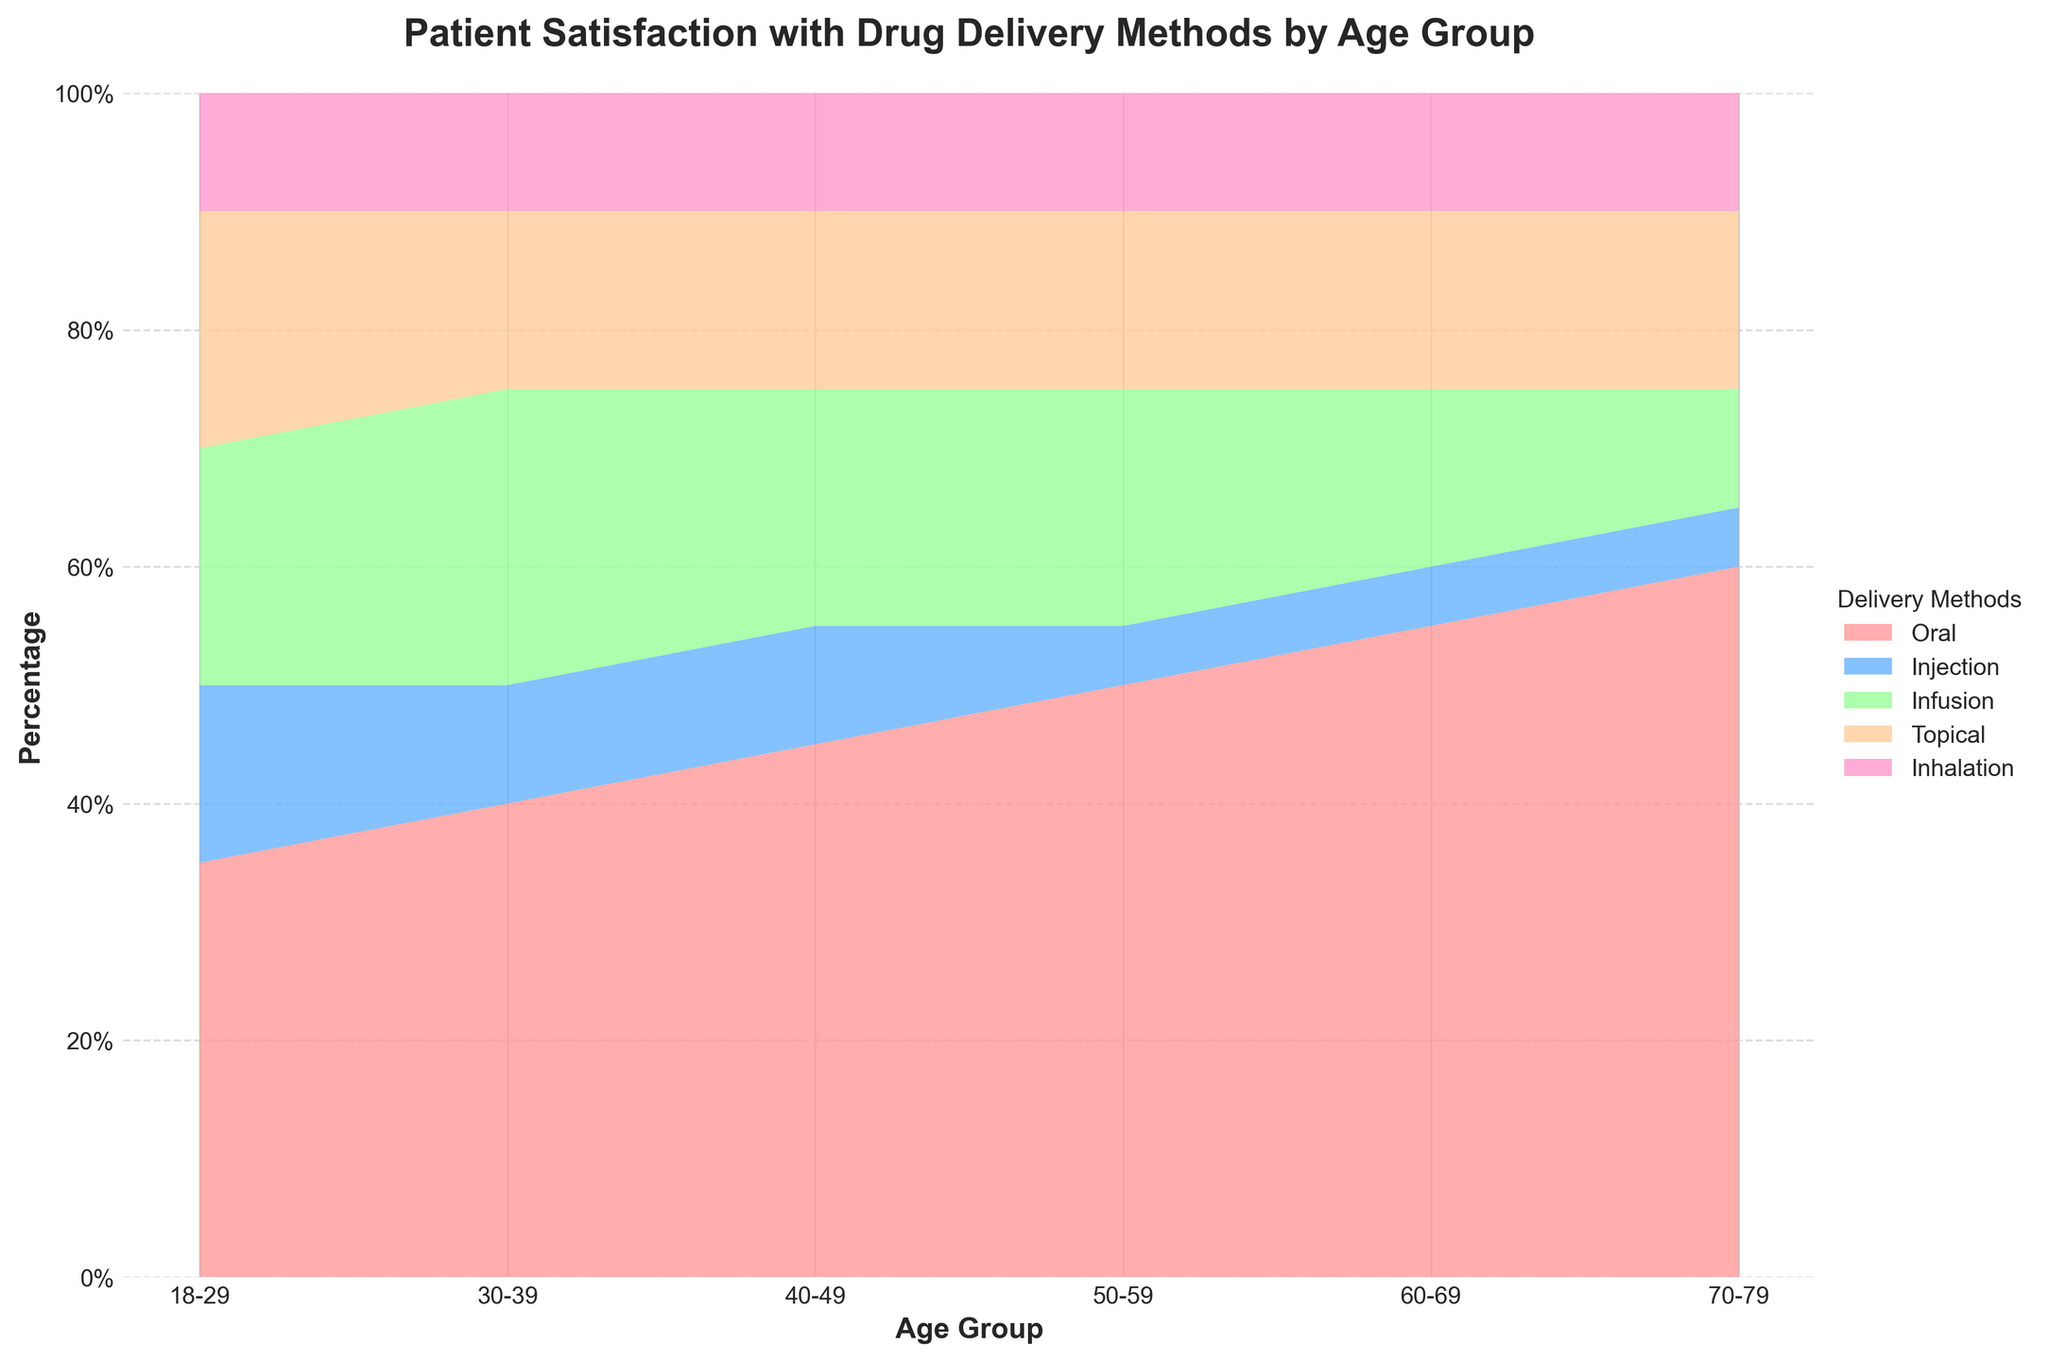What is the title of the chart? The title is displayed at the top of the chart, providing an overview of what the data represents.
Answer: Patient Satisfaction with Drug Delivery Methods by Age Group Which age group has the highest percentage of satisfaction with oral drug delivery? The height of the segment representing oral drug delivery across different age groups shows the highest percentage in the 70-79 age group.
Answer: 70-79 Which drug delivery method consistently has the lowest percentage across all age groups? By examining the segments, injection always occupies the lowest or close to the lowest area in each age group.
Answer: Injection What is the approximate percentage of patient satisfaction with infusion in the 30-39 age group? The infusion segment for the 30-39 age group closely aligns with a value of approximately 25%.
Answer: 25% How do the satisfaction levels for topical delivery change across age groups? Observing the stacked areas of topical delivery indicates it remains fairly constant at around 15%.
Answer: Fairly constant at 15% Compare the satisfaction levels of oral delivery between the 18-29 and 50-59 age groups. Oral satisfaction is around 35% for the 18-29 age group and approximately 50% for the 50-59 age group.
Answer: Higher in 50-59 In which age group is the satisfaction with inhalation the same? Observing the inhalation segment, its percentage remains consistent at 10% across all age groups.
Answer: All age groups Calculate the combined percentage of satisfaction for injection and inhalation in the 60-69 age group. Injection is 5% and inhalation is 10%, adding these yields 15%.
Answer: 15% Determine which delivery method has the most significant increase in satisfaction as the age increases from 18-29 to 70-79. Examining the oral delivery section reveals a steady increase from 35% to 60%.
Answer: Oral What is the difference in satisfaction with topical drug delivery between the 30-39 and 70-79 age groups? Both age groups show 15% satisfaction with topical drug delivery, resulting in no difference.
Answer: 0% 